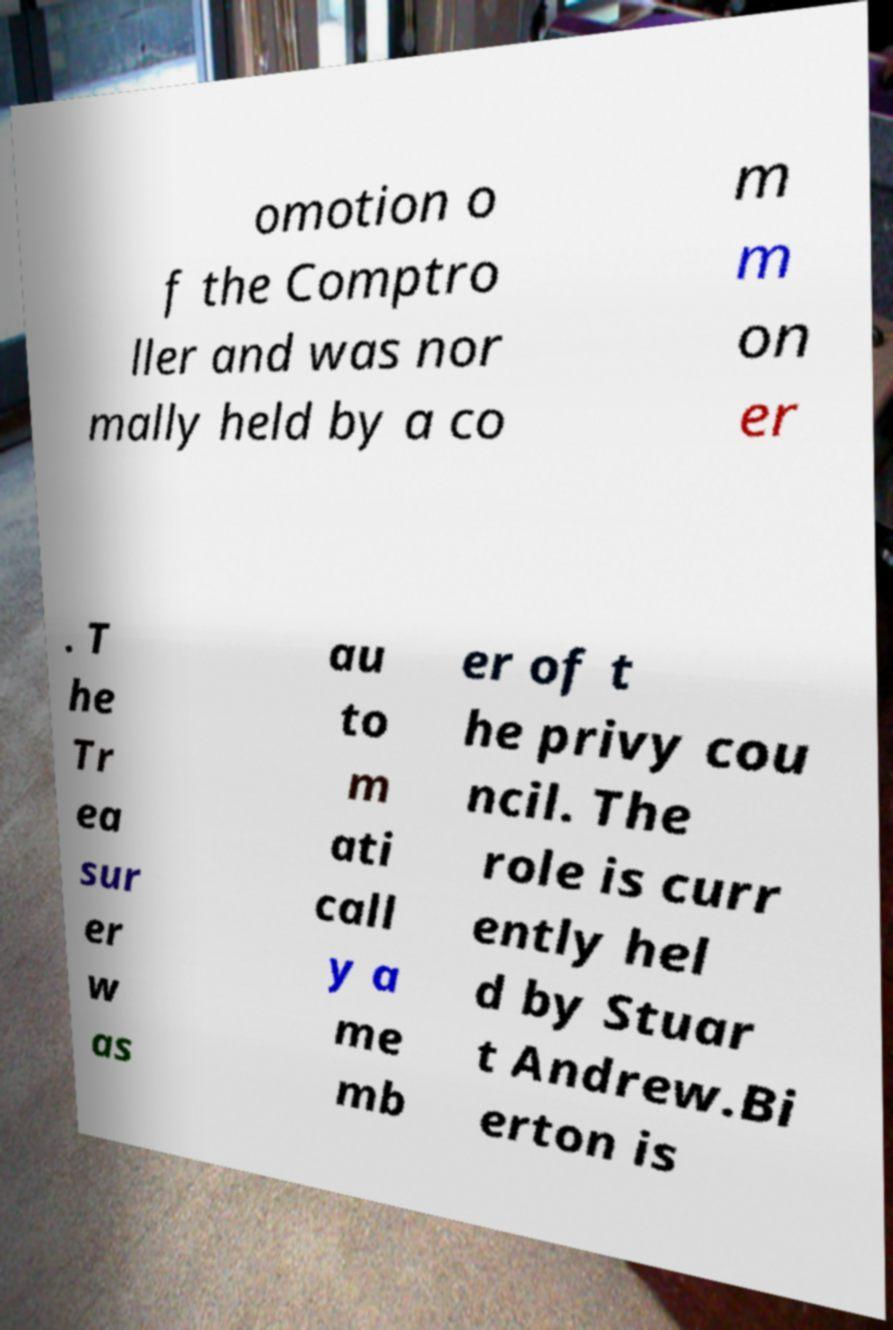Please read and relay the text visible in this image. What does it say? omotion o f the Comptro ller and was nor mally held by a co m m on er . T he Tr ea sur er w as au to m ati call y a me mb er of t he privy cou ncil. The role is curr ently hel d by Stuar t Andrew.Bi erton is 